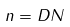<formula> <loc_0><loc_0><loc_500><loc_500>n = D N</formula> 